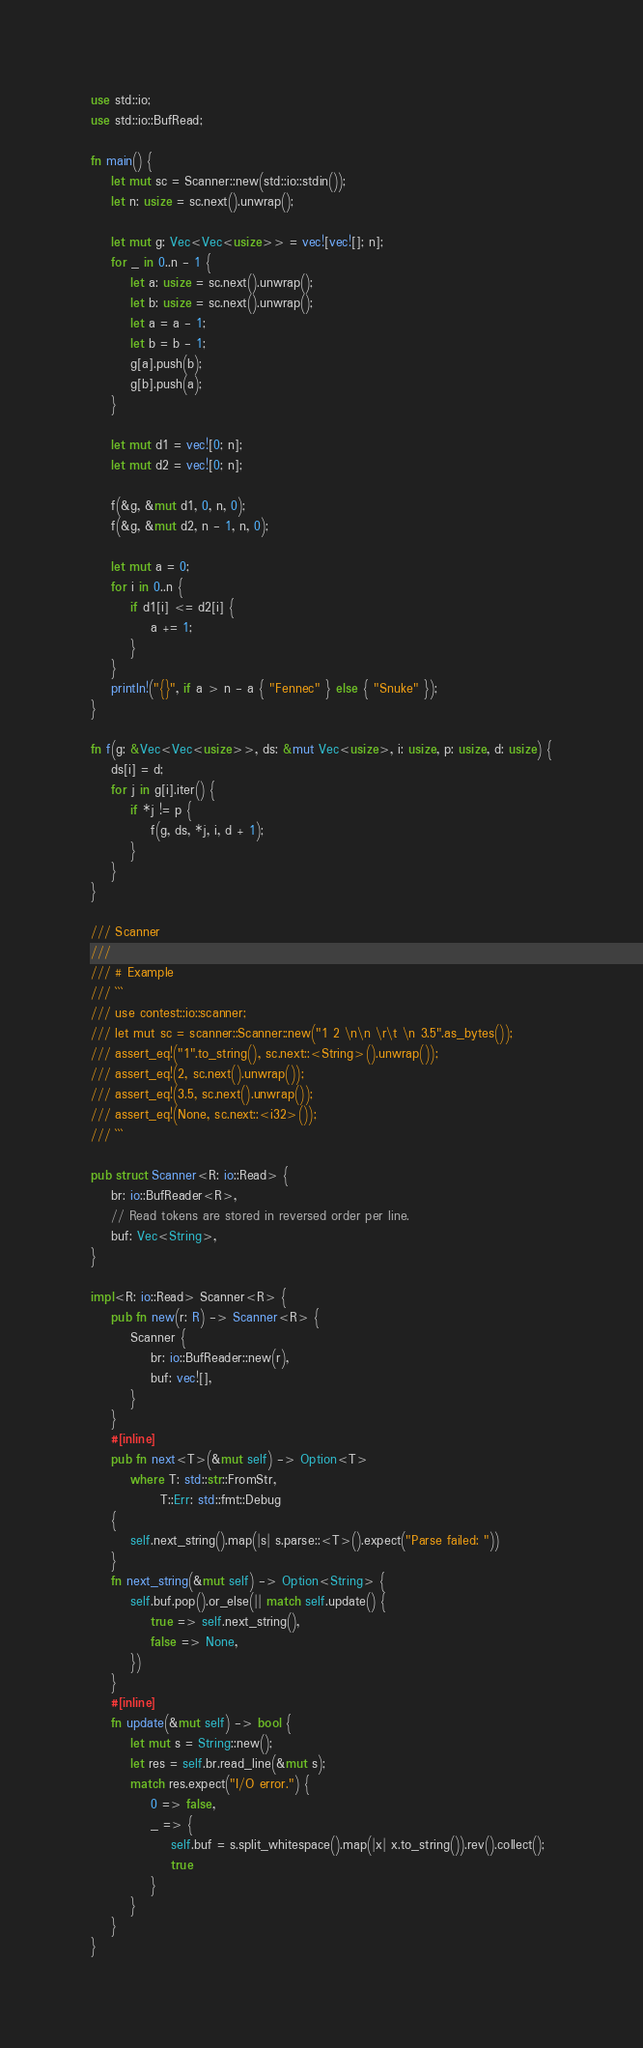Convert code to text. <code><loc_0><loc_0><loc_500><loc_500><_Rust_>use std::io;
use std::io::BufRead;

fn main() {
    let mut sc = Scanner::new(std::io::stdin());
    let n: usize = sc.next().unwrap();

    let mut g: Vec<Vec<usize>> = vec![vec![]; n];
    for _ in 0..n - 1 {
        let a: usize = sc.next().unwrap();
        let b: usize = sc.next().unwrap();
        let a = a - 1;
        let b = b - 1;
        g[a].push(b);
        g[b].push(a);
    }

    let mut d1 = vec![0; n];
    let mut d2 = vec![0; n];

    f(&g, &mut d1, 0, n, 0);
    f(&g, &mut d2, n - 1, n, 0);

    let mut a = 0;
    for i in 0..n {
        if d1[i] <= d2[i] {
            a += 1;
        }
    }
    println!("{}", if a > n - a { "Fennec" } else { "Snuke" });
}

fn f(g: &Vec<Vec<usize>>, ds: &mut Vec<usize>, i: usize, p: usize, d: usize) {
    ds[i] = d;
    for j in g[i].iter() {
        if *j != p {
            f(g, ds, *j, i, d + 1);
        }
    }
}

/// Scanner
///
/// # Example
/// ```
/// use contest::io::scanner;
/// let mut sc = scanner::Scanner::new("1 2 \n\n \r\t \n 3.5".as_bytes());
/// assert_eq!("1".to_string(), sc.next::<String>().unwrap());
/// assert_eq!(2, sc.next().unwrap());
/// assert_eq!(3.5, sc.next().unwrap());
/// assert_eq!(None, sc.next::<i32>());
/// ```

pub struct Scanner<R: io::Read> {
    br: io::BufReader<R>,
    // Read tokens are stored in reversed order per line.
    buf: Vec<String>,
}

impl<R: io::Read> Scanner<R> {
    pub fn new(r: R) -> Scanner<R> {
        Scanner {
            br: io::BufReader::new(r),
            buf: vec![],
        }
    }
    #[inline]
    pub fn next<T>(&mut self) -> Option<T>
        where T: std::str::FromStr,
              T::Err: std::fmt::Debug
    {
        self.next_string().map(|s| s.parse::<T>().expect("Parse failed: "))
    }
    fn next_string(&mut self) -> Option<String> {
        self.buf.pop().or_else(|| match self.update() {
            true => self.next_string(),
            false => None,
        })
    }
    #[inline]
    fn update(&mut self) -> bool {
        let mut s = String::new();
        let res = self.br.read_line(&mut s);
        match res.expect("I/O error.") {
            0 => false,
            _ => {
                self.buf = s.split_whitespace().map(|x| x.to_string()).rev().collect();
                true
            }
        }
    }
}
</code> 